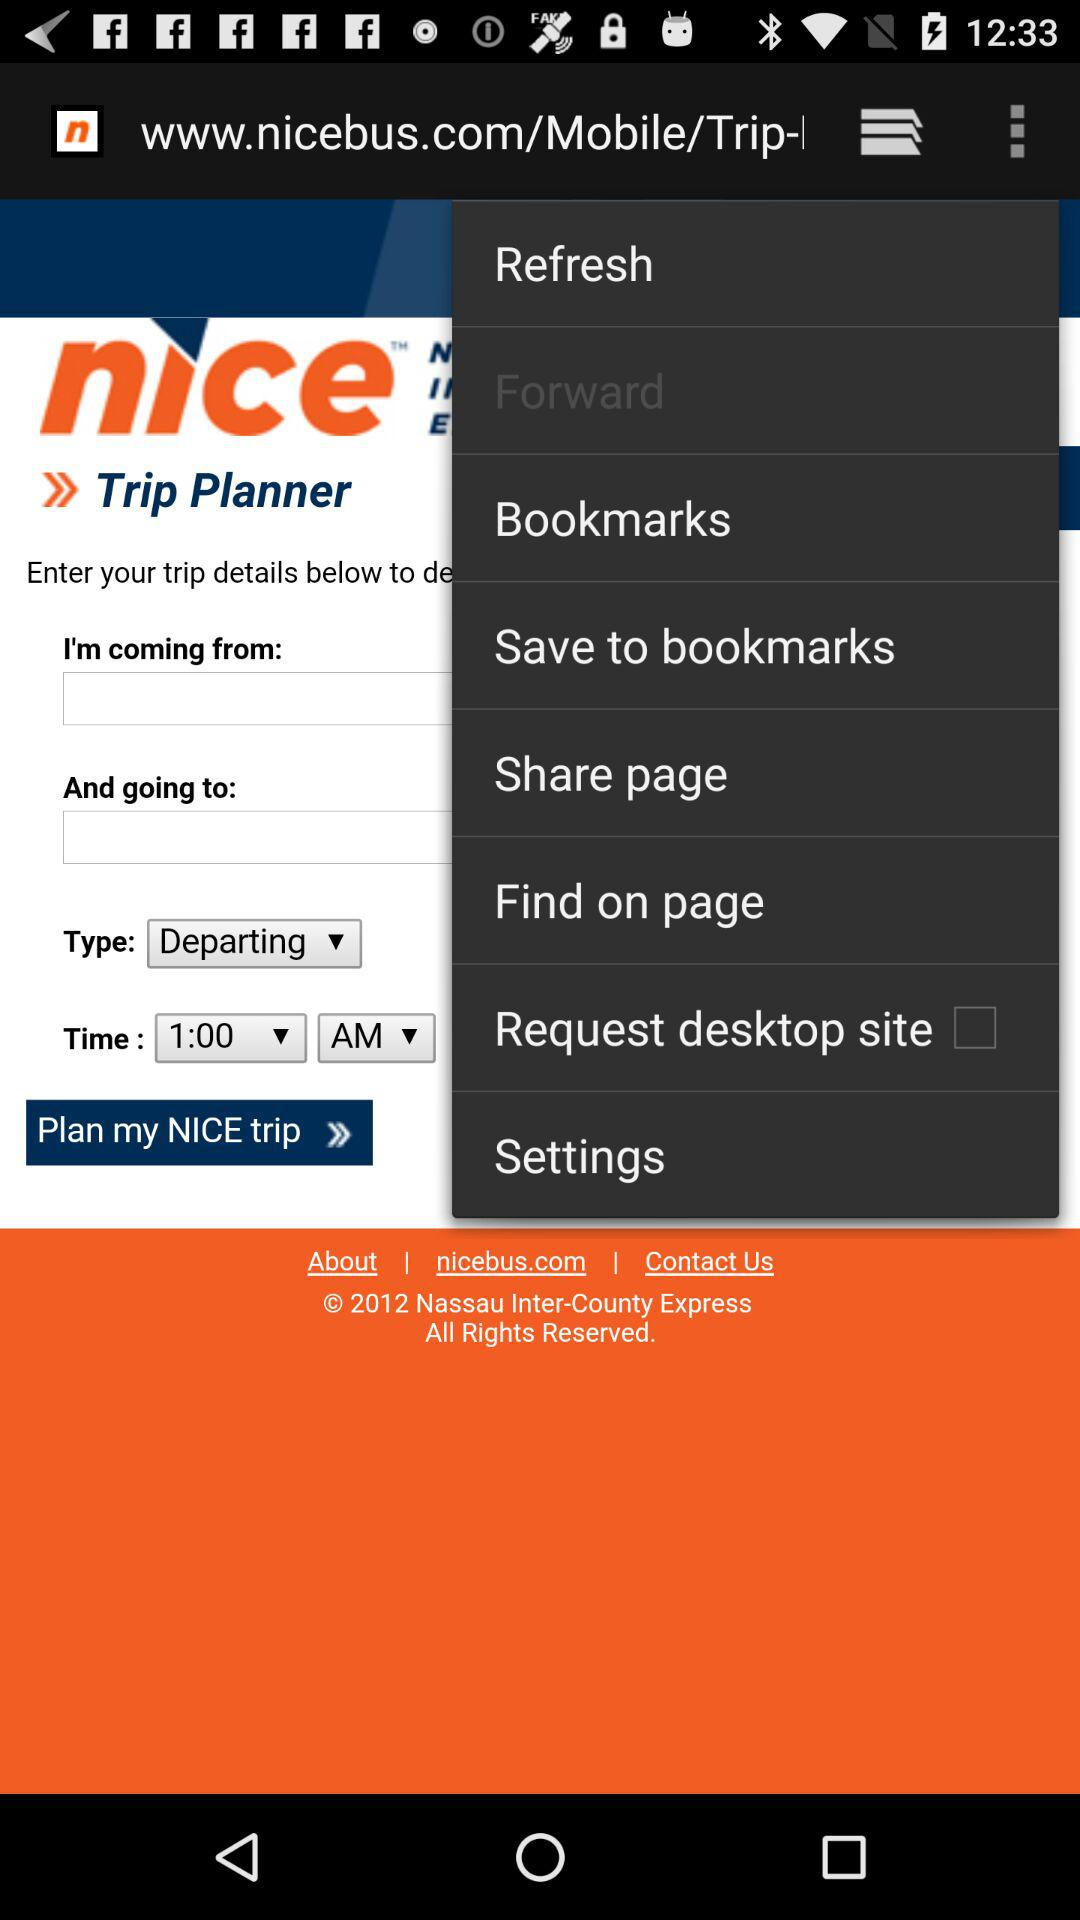What is the version of the application?
When the provided information is insufficient, respond with <no answer>. <no answer> 